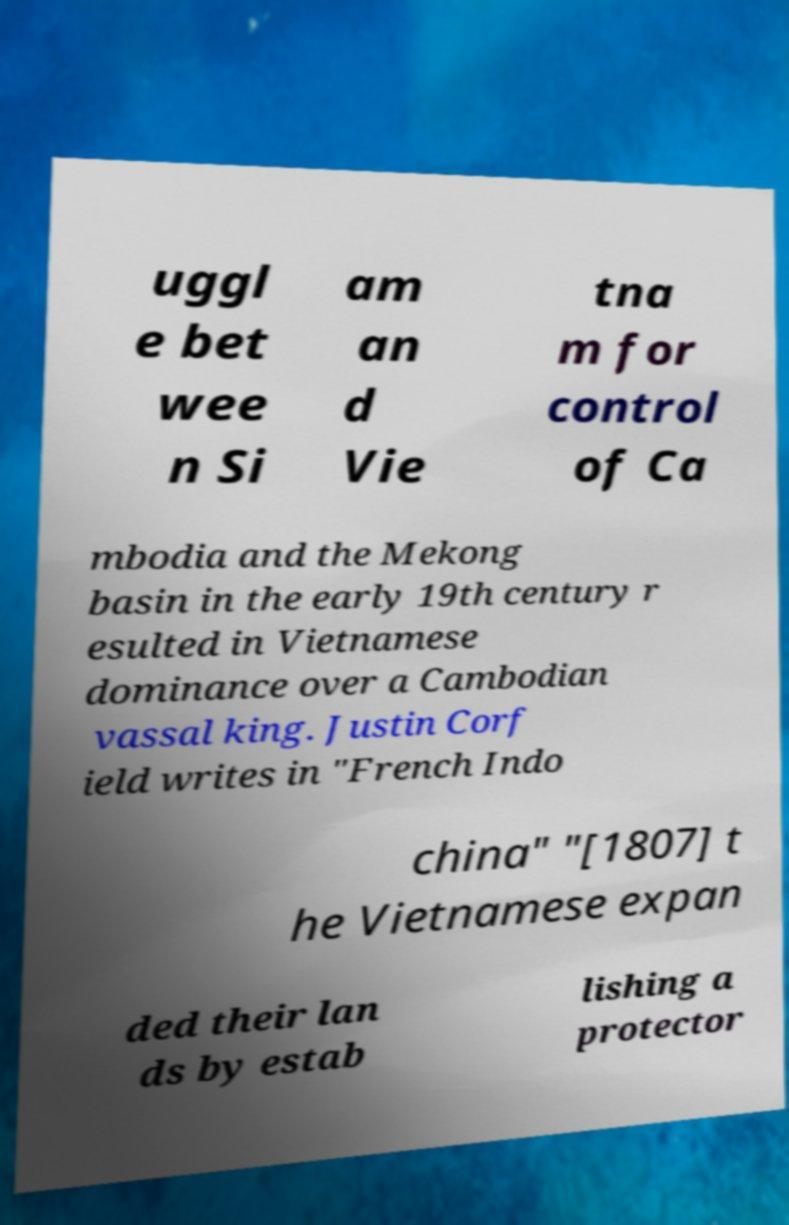Can you accurately transcribe the text from the provided image for me? uggl e bet wee n Si am an d Vie tna m for control of Ca mbodia and the Mekong basin in the early 19th century r esulted in Vietnamese dominance over a Cambodian vassal king. Justin Corf ield writes in "French Indo china" "[1807] t he Vietnamese expan ded their lan ds by estab lishing a protector 